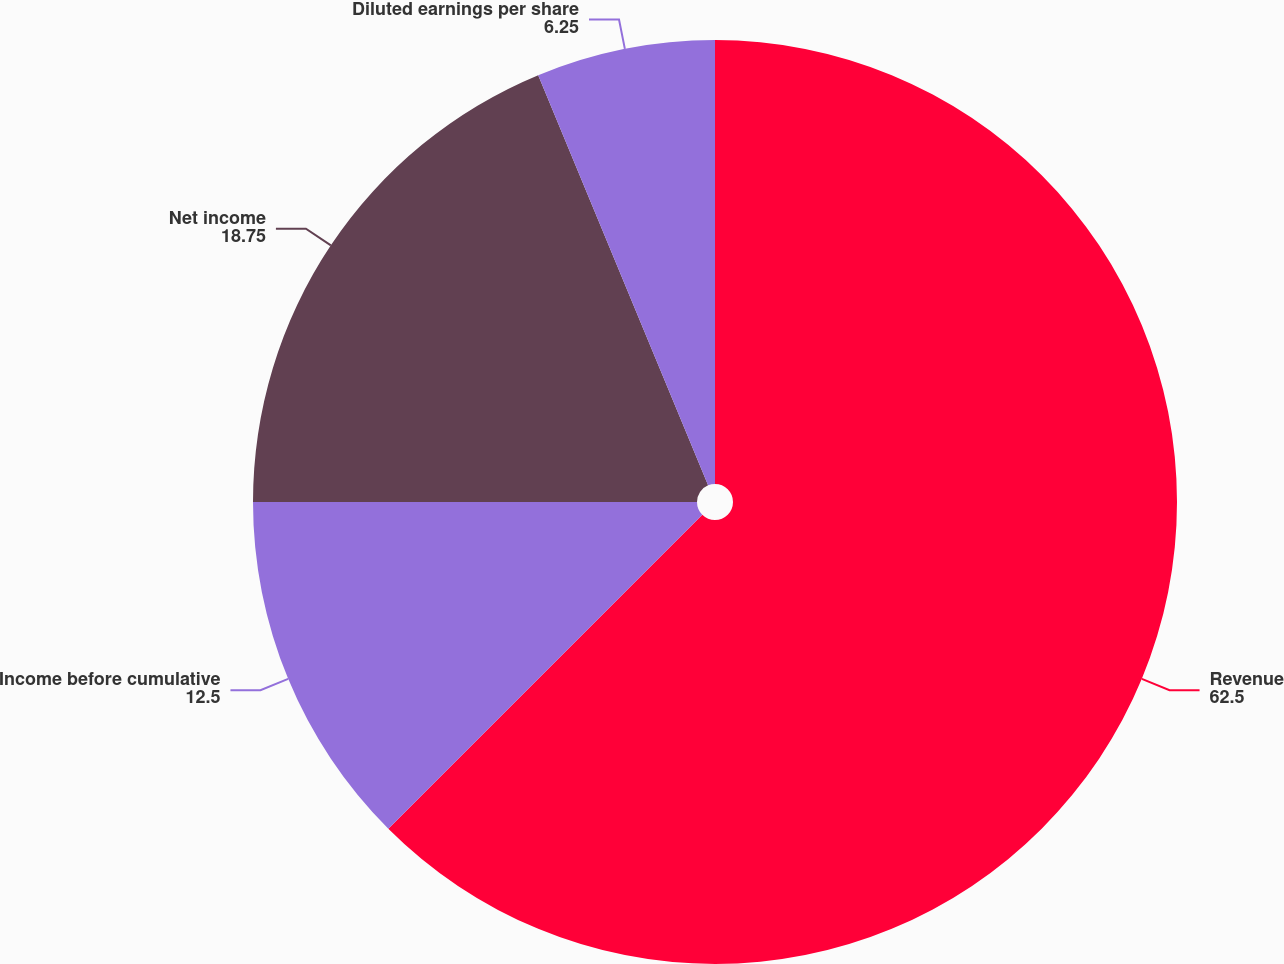<chart> <loc_0><loc_0><loc_500><loc_500><pie_chart><fcel>Revenue<fcel>Income before cumulative<fcel>Net income<fcel>Diluted earnings per share<nl><fcel>62.5%<fcel>12.5%<fcel>18.75%<fcel>6.25%<nl></chart> 